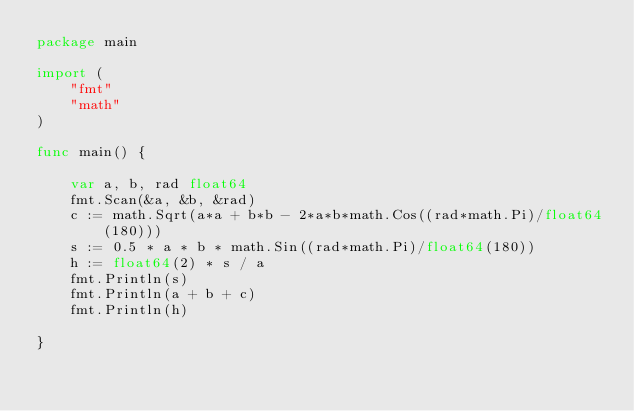<code> <loc_0><loc_0><loc_500><loc_500><_Go_>package main

import (
	"fmt"
	"math"
)

func main() {

	var a, b, rad float64
	fmt.Scan(&a, &b, &rad)
	c := math.Sqrt(a*a + b*b - 2*a*b*math.Cos((rad*math.Pi)/float64(180)))
	s := 0.5 * a * b * math.Sin((rad*math.Pi)/float64(180))
	h := float64(2) * s / a
	fmt.Println(s)
	fmt.Println(a + b + c)
	fmt.Println(h)

}

</code> 